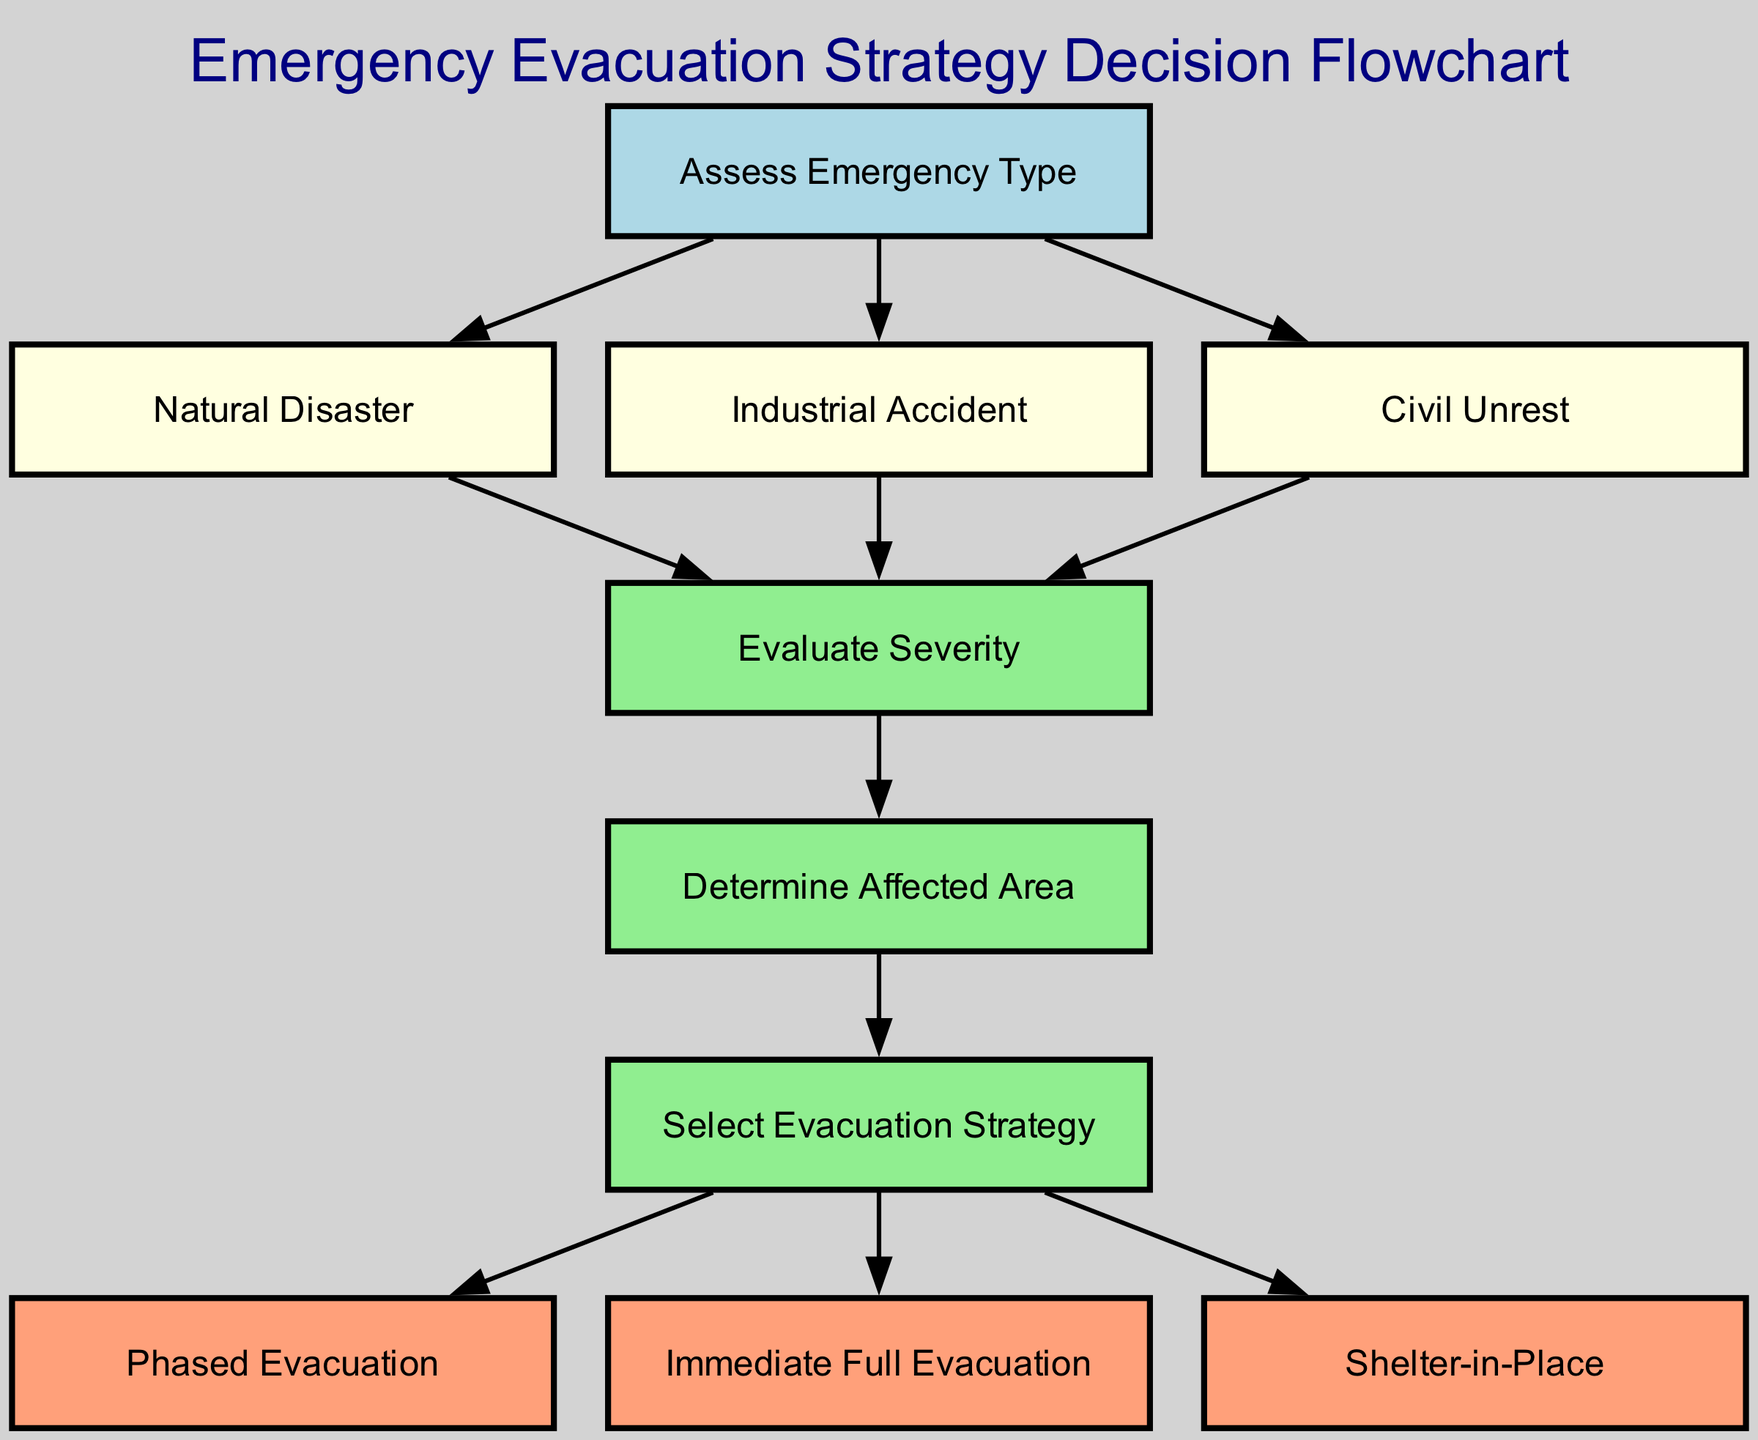What is the first step in the decision-making process? The flowchart begins with the node labeled "Assess Emergency Type," which is the starting point of the decision-making process.
Answer: Assess Emergency Type How many types of emergencies are identified in this diagram? The diagram identifies three types of emergencies: Natural Disaster, Industrial Accident, and Civil Unrest, represented as separate nodes.
Answer: Three What is the node associated with evaluating severity? The diagram has a node labeled "Evaluate Severity," which follows the identification of the emergency type.
Answer: Evaluate Severity Which evacuation strategy is selected for a serious emergency? For a serious emergency, the decision-making leads to the option of "Immediate Full Evacuation," which is specifically designated for such situations in the flowchart.
Answer: Immediate Full Evacuation What is the relationship between "Determine Affected Area" and "Select Evacuation Strategy"? "Determine Affected Area" is directly necessary for "Select Evacuation Strategy," indicating that understanding the areas affected is crucial for making an evacuation decision.
Answer: Direct relationship How many evacuation strategies are available based on the decision-making process? The diagram outlines three possible evacuation strategies: Phased Evacuation, Immediate Full Evacuation, and Shelter-in-Place, sequentially from the "Select Evacuation Strategy" node.
Answer: Three What influences the choice of a phased evacuation? A phased evacuation is appropriate when the decision-making process leads to that specific evacuation strategy based on the evaluation of emergency severity and affected areas.
Answer: Evaluation of severity If the emergency type is an industrial accident, how is the next step determined? Following the industrial accident node, the next step is to "Evaluate Severity," showing that this evaluation is necessary regardless of the emergency type.
Answer: Evaluate Severity Which evacuation strategy is recommended for less severe emergencies? For less severe emergencies, the strategy selected can be "Shelter-in-Place," suggesting that this approach is suitable based on the evaluation of the situation.
Answer: Shelter-in-Place 